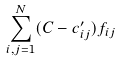Convert formula to latex. <formula><loc_0><loc_0><loc_500><loc_500>\sum _ { i , j = 1 } ^ { N } ( C - c ^ { \prime } _ { i j } ) f _ { i j }</formula> 